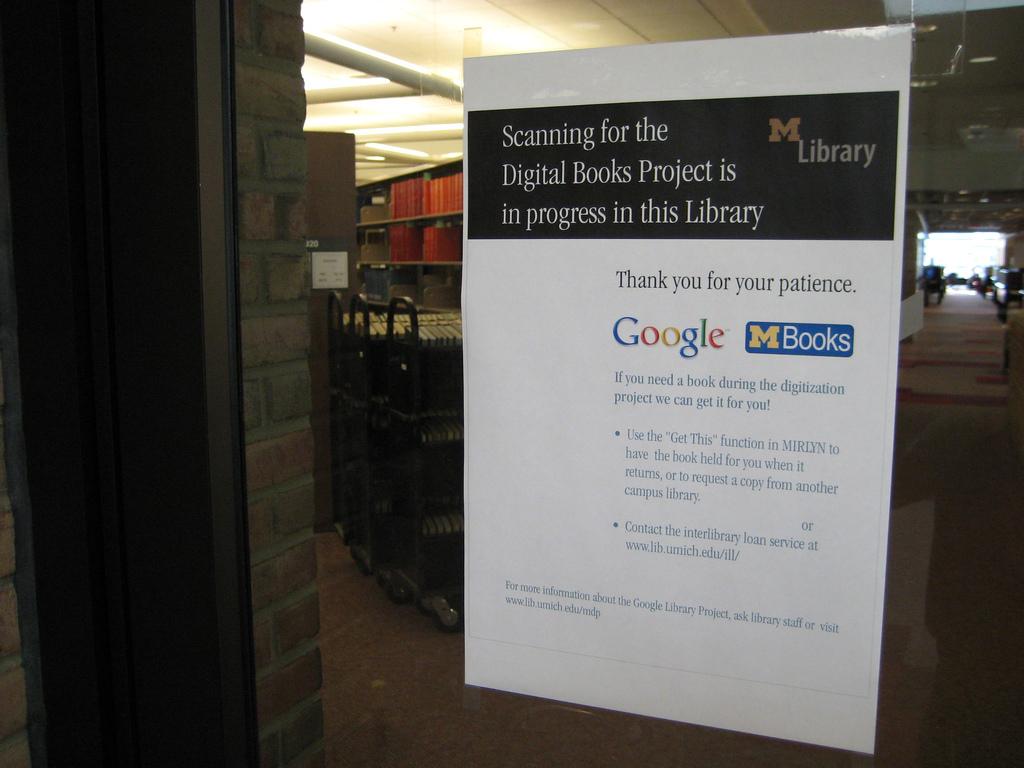What is google advertising?
Offer a terse response. Mbooks. What kind of books?
Your answer should be very brief. Digital. 